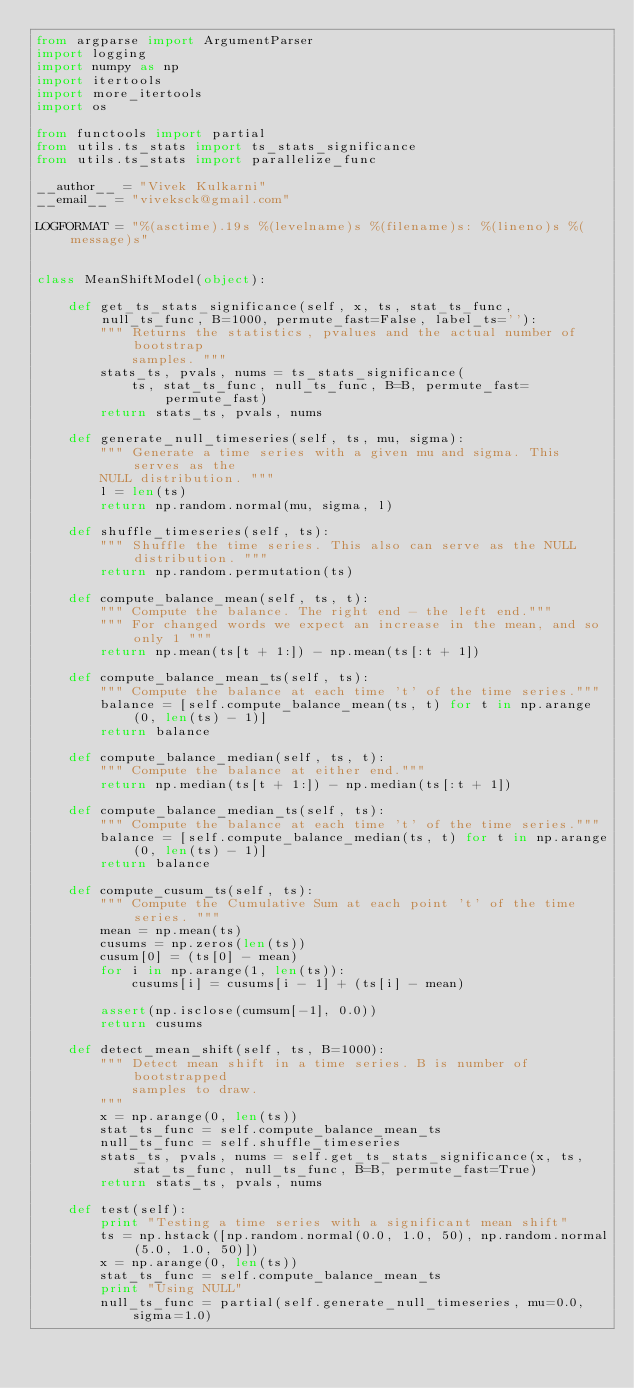Convert code to text. <code><loc_0><loc_0><loc_500><loc_500><_Python_>from argparse import ArgumentParser
import logging
import numpy as np
import itertools
import more_itertools
import os

from functools import partial
from utils.ts_stats import ts_stats_significance
from utils.ts_stats import parallelize_func

__author__ = "Vivek Kulkarni"
__email__ = "viveksck@gmail.com"

LOGFORMAT = "%(asctime).19s %(levelname)s %(filename)s: %(lineno)s %(message)s"


class MeanShiftModel(object):

    def get_ts_stats_significance(self, x, ts, stat_ts_func, null_ts_func, B=1000, permute_fast=False, label_ts=''):
        """ Returns the statistics, pvalues and the actual number of bootstrap
            samples. """
        stats_ts, pvals, nums = ts_stats_significance(
            ts, stat_ts_func, null_ts_func, B=B, permute_fast=permute_fast)
        return stats_ts, pvals, nums

    def generate_null_timeseries(self, ts, mu, sigma):
        """ Generate a time series with a given mu and sigma. This serves as the
        NULL distribution. """
        l = len(ts)
        return np.random.normal(mu, sigma, l)

    def shuffle_timeseries(self, ts):
        """ Shuffle the time series. This also can serve as the NULL distribution. """
        return np.random.permutation(ts)

    def compute_balance_mean(self, ts, t):
        """ Compute the balance. The right end - the left end."""
        """ For changed words we expect an increase in the mean, and so only 1 """
        return np.mean(ts[t + 1:]) - np.mean(ts[:t + 1])

    def compute_balance_mean_ts(self, ts):
        """ Compute the balance at each time 't' of the time series."""
        balance = [self.compute_balance_mean(ts, t) for t in np.arange(0, len(ts) - 1)]
        return balance

    def compute_balance_median(self, ts, t):
        """ Compute the balance at either end."""
        return np.median(ts[t + 1:]) - np.median(ts[:t + 1])

    def compute_balance_median_ts(self, ts):
        """ Compute the balance at each time 't' of the time series."""
        balance = [self.compute_balance_median(ts, t) for t in np.arange(0, len(ts) - 1)]
        return balance

    def compute_cusum_ts(self, ts):
        """ Compute the Cumulative Sum at each point 't' of the time series. """
        mean = np.mean(ts)
        cusums = np.zeros(len(ts))
        cusum[0] = (ts[0] - mean)
        for i in np.arange(1, len(ts)):
            cusums[i] = cusums[i - 1] + (ts[i] - mean)

        assert(np.isclose(cumsum[-1], 0.0))
        return cusums

    def detect_mean_shift(self, ts, B=1000):
        """ Detect mean shift in a time series. B is number of bootstrapped
            samples to draw.
        """
        x = np.arange(0, len(ts))
        stat_ts_func = self.compute_balance_mean_ts
        null_ts_func = self.shuffle_timeseries
        stats_ts, pvals, nums = self.get_ts_stats_significance(x, ts, stat_ts_func, null_ts_func, B=B, permute_fast=True)
        return stats_ts, pvals, nums

    def test(self):
        print "Testing a time series with a significant mean shift"
        ts = np.hstack([np.random.normal(0.0, 1.0, 50), np.random.normal(5.0, 1.0, 50)])
        x = np.arange(0, len(ts))
        stat_ts_func = self.compute_balance_mean_ts
        print "Using NULL"
        null_ts_func = partial(self.generate_null_timeseries, mu=0.0, sigma=1.0)</code> 